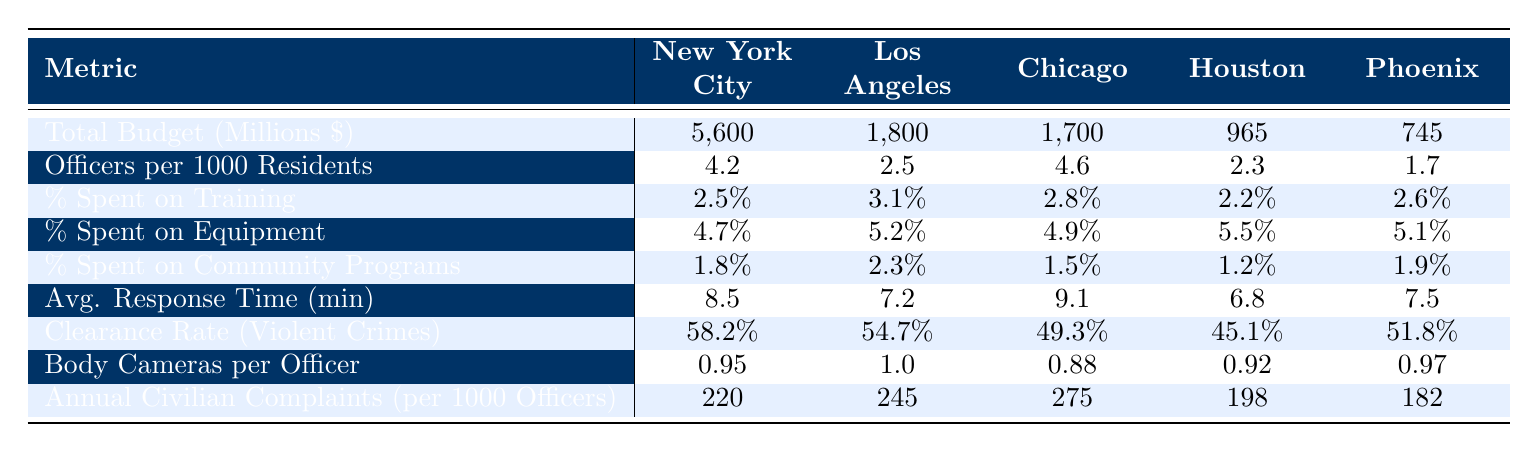What is the total budget for New York City in millions? The table lists the total budget for New York City as 5,600 million dollars.
Answer: 5600 How many officers are there per 1000 residents in Chicago? According to the table, Chicago has 4.6 officers per 1000 residents.
Answer: 4.6 Which city has the highest percentage spent on equipment? By examining the table, Los Angeles has the highest percentage spent on equipment at 5.2%.
Answer: 5.2% Is the average response time in Houston less than that of Los Angeles? The average response time in Houston is 6.8 minutes, while it is 7.2 minutes in Los Angeles. Since 6.8 is less than 7.2, the statement is true.
Answer: Yes What is the clearance rate for violent crimes in Phoenix? Looking at the table, the clearance rate for violent crimes in Phoenix is 51.8%.
Answer: 51.8% Which city has the lowest annual civilian complaints per 1000 officers? The table shows Houston has the lowest number of annual civilian complaints per 1000 officers at 198.
Answer: 198 What is the average percentage spent on training across all listed cities? The percentages for each city are 2.5%, 3.1%, 2.8%, 2.2%, and 2.6%. Summing these gives 13.2%. Dividing by 5 gives an average of 2.64%.
Answer: 2.64% Is Chicago spending more on community programs than Houston? The table shows Chicago spends 1.5% while Houston spends 1.2%. Since 1.5% is greater than 1.2%, the answer is yes.
Answer: Yes How does the number of body cameras per officer in Los Angeles compare with that in New York City? Los Angeles has 1.0 body cameras per officer while New York City has 0.95. Comparing these, 1.0 is greater than 0.95.
Answer: 1.0 is greater What is the difference in total budget between New York City and Phoenix? The total budget for New York City is 5,600 million and for Phoenix it is 745 million. The difference is 5600 - 745 = 4855 million.
Answer: 4855 million Which city has the best clearance rate for violent crimes? The best clearance rate in the table belongs to New York City, which has a rate of 58.2%.
Answer: 58.2% 